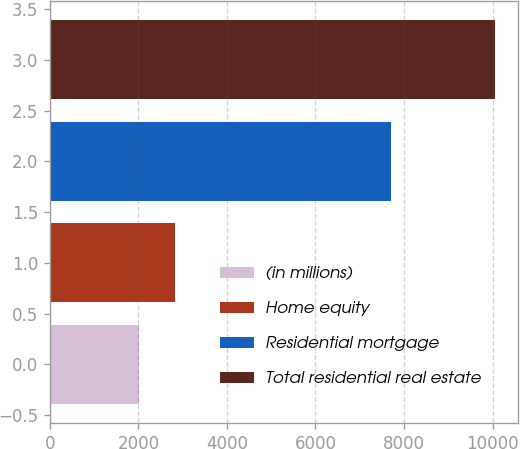Convert chart. <chart><loc_0><loc_0><loc_500><loc_500><bar_chart><fcel>(in millions)<fcel>Home equity<fcel>Residential mortgage<fcel>Total residential real estate<nl><fcel>2015<fcel>2820.1<fcel>7697<fcel>10066<nl></chart> 